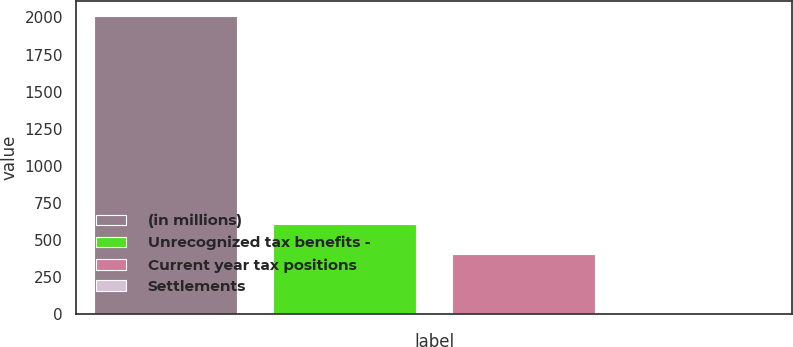Convert chart. <chart><loc_0><loc_0><loc_500><loc_500><bar_chart><fcel>(in millions)<fcel>Unrecognized tax benefits -<fcel>Current year tax positions<fcel>Settlements<nl><fcel>2013<fcel>604.6<fcel>403.4<fcel>1<nl></chart> 